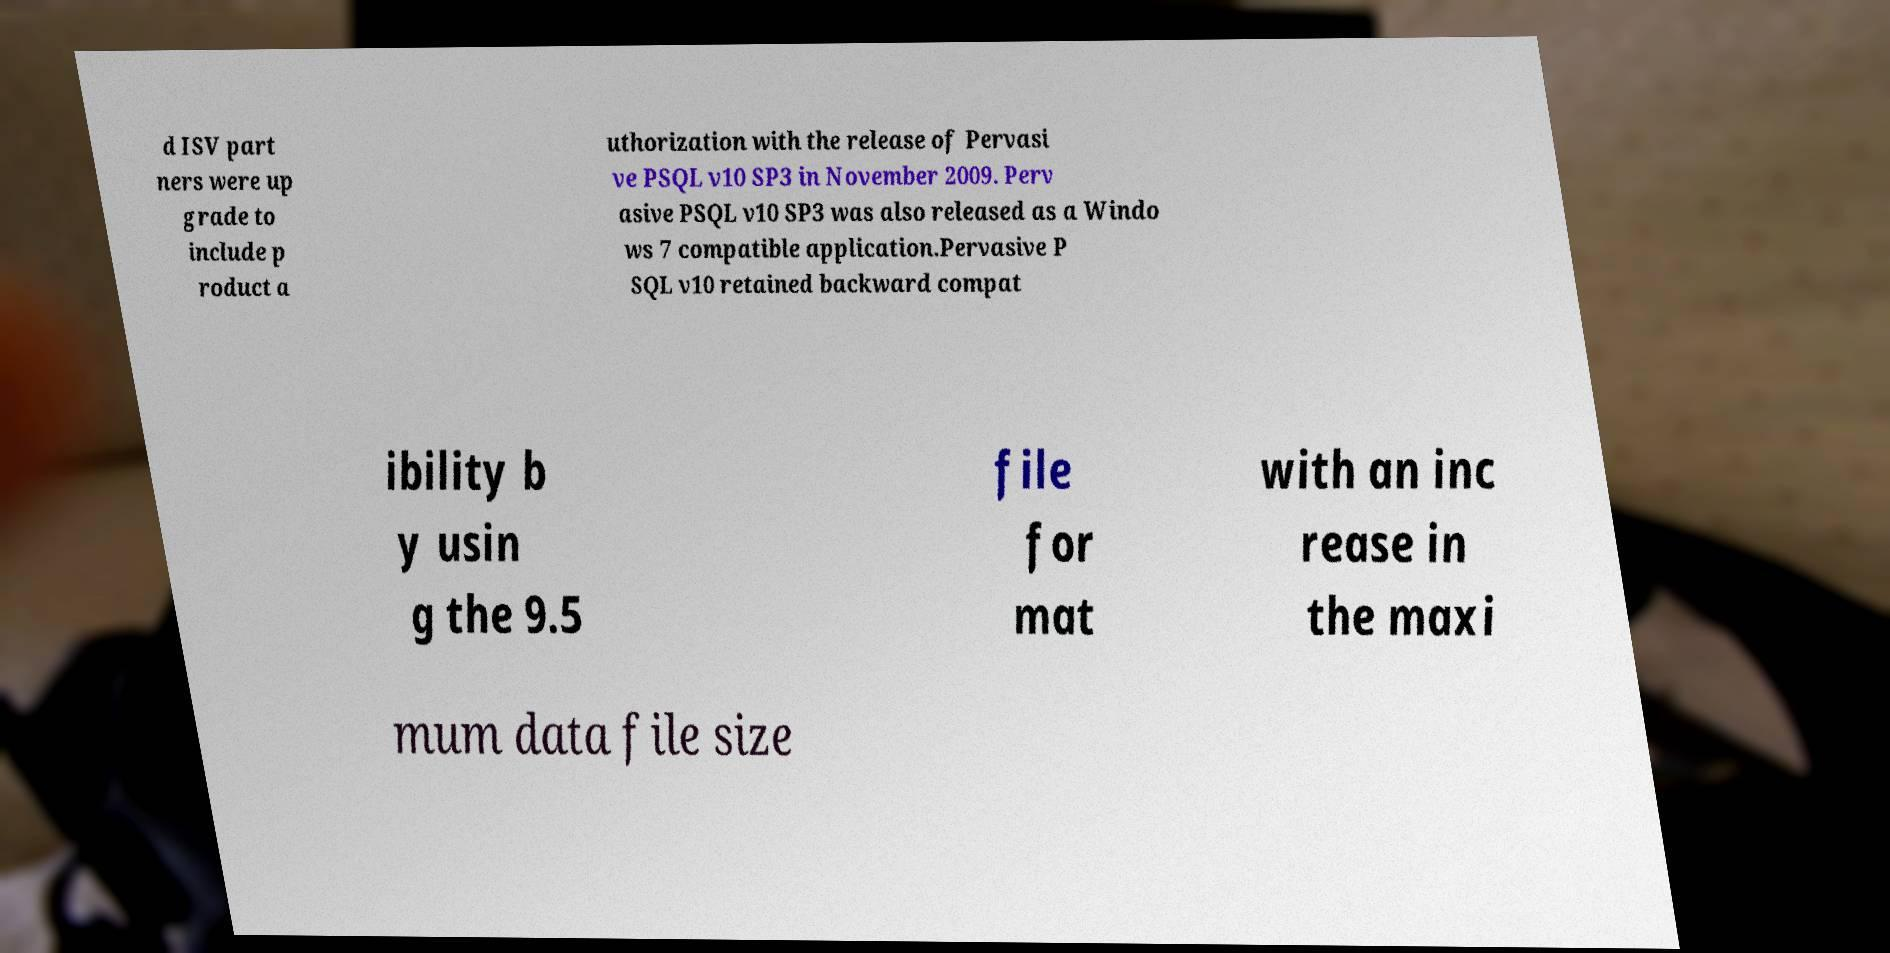Please read and relay the text visible in this image. What does it say? d ISV part ners were up grade to include p roduct a uthorization with the release of Pervasi ve PSQL v10 SP3 in November 2009. Perv asive PSQL v10 SP3 was also released as a Windo ws 7 compatible application.Pervasive P SQL v10 retained backward compat ibility b y usin g the 9.5 file for mat with an inc rease in the maxi mum data file size 